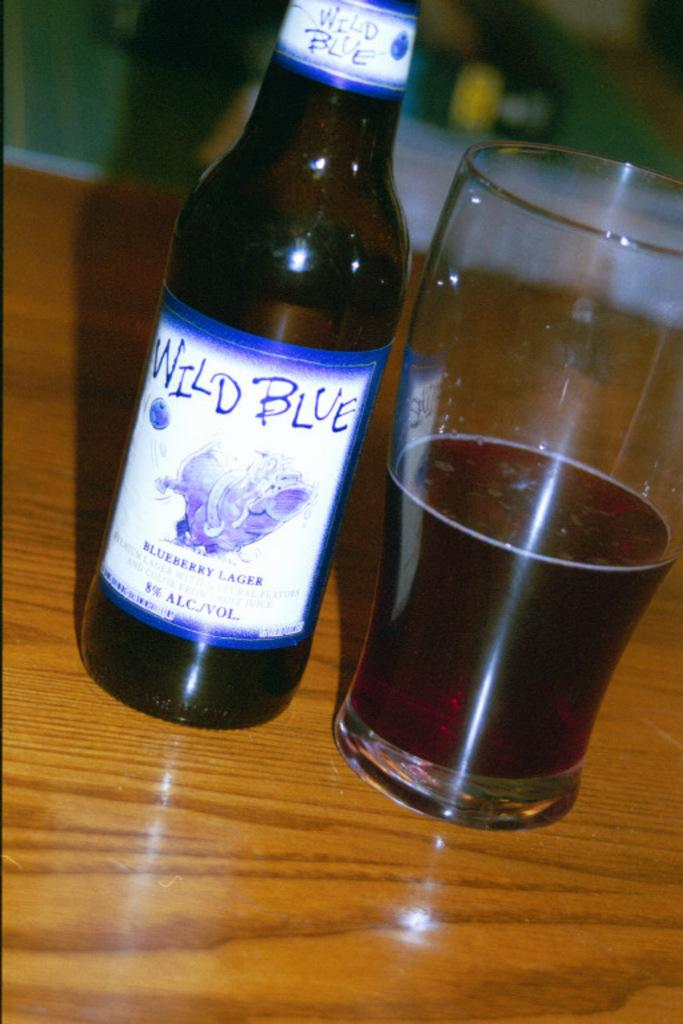Provide a one-sentence caption for the provided image. A bottle of Wild Blue Blueberry Lager next to a half full beer glass. 